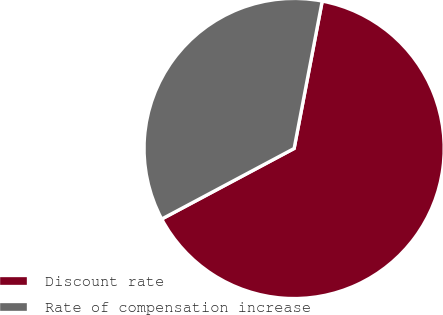<chart> <loc_0><loc_0><loc_500><loc_500><pie_chart><fcel>Discount rate<fcel>Rate of compensation increase<nl><fcel>64.21%<fcel>35.79%<nl></chart> 